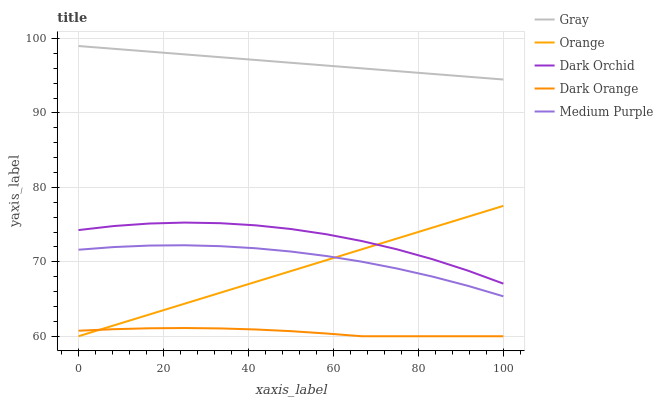Does Dark Orange have the minimum area under the curve?
Answer yes or no. Yes. Does Gray have the maximum area under the curve?
Answer yes or no. Yes. Does Medium Purple have the minimum area under the curve?
Answer yes or no. No. Does Medium Purple have the maximum area under the curve?
Answer yes or no. No. Is Orange the smoothest?
Answer yes or no. Yes. Is Dark Orchid the roughest?
Answer yes or no. Yes. Is Gray the smoothest?
Answer yes or no. No. Is Gray the roughest?
Answer yes or no. No. Does Orange have the lowest value?
Answer yes or no. Yes. Does Medium Purple have the lowest value?
Answer yes or no. No. Does Gray have the highest value?
Answer yes or no. Yes. Does Medium Purple have the highest value?
Answer yes or no. No. Is Medium Purple less than Gray?
Answer yes or no. Yes. Is Dark Orchid greater than Medium Purple?
Answer yes or no. Yes. Does Orange intersect Dark Orchid?
Answer yes or no. Yes. Is Orange less than Dark Orchid?
Answer yes or no. No. Is Orange greater than Dark Orchid?
Answer yes or no. No. Does Medium Purple intersect Gray?
Answer yes or no. No. 